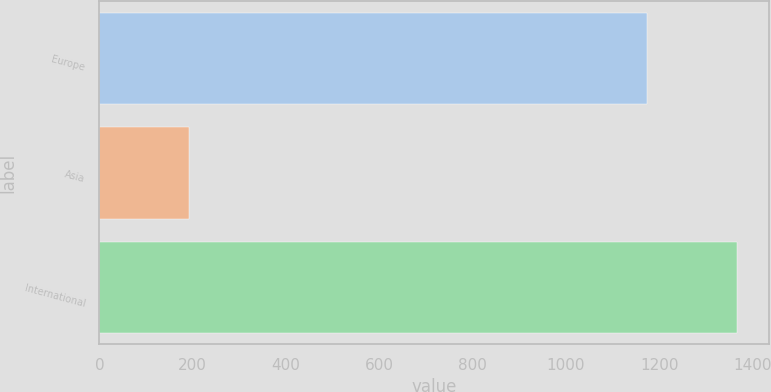<chart> <loc_0><loc_0><loc_500><loc_500><bar_chart><fcel>Europe<fcel>Asia<fcel>International<nl><fcel>1174<fcel>193<fcel>1367<nl></chart> 